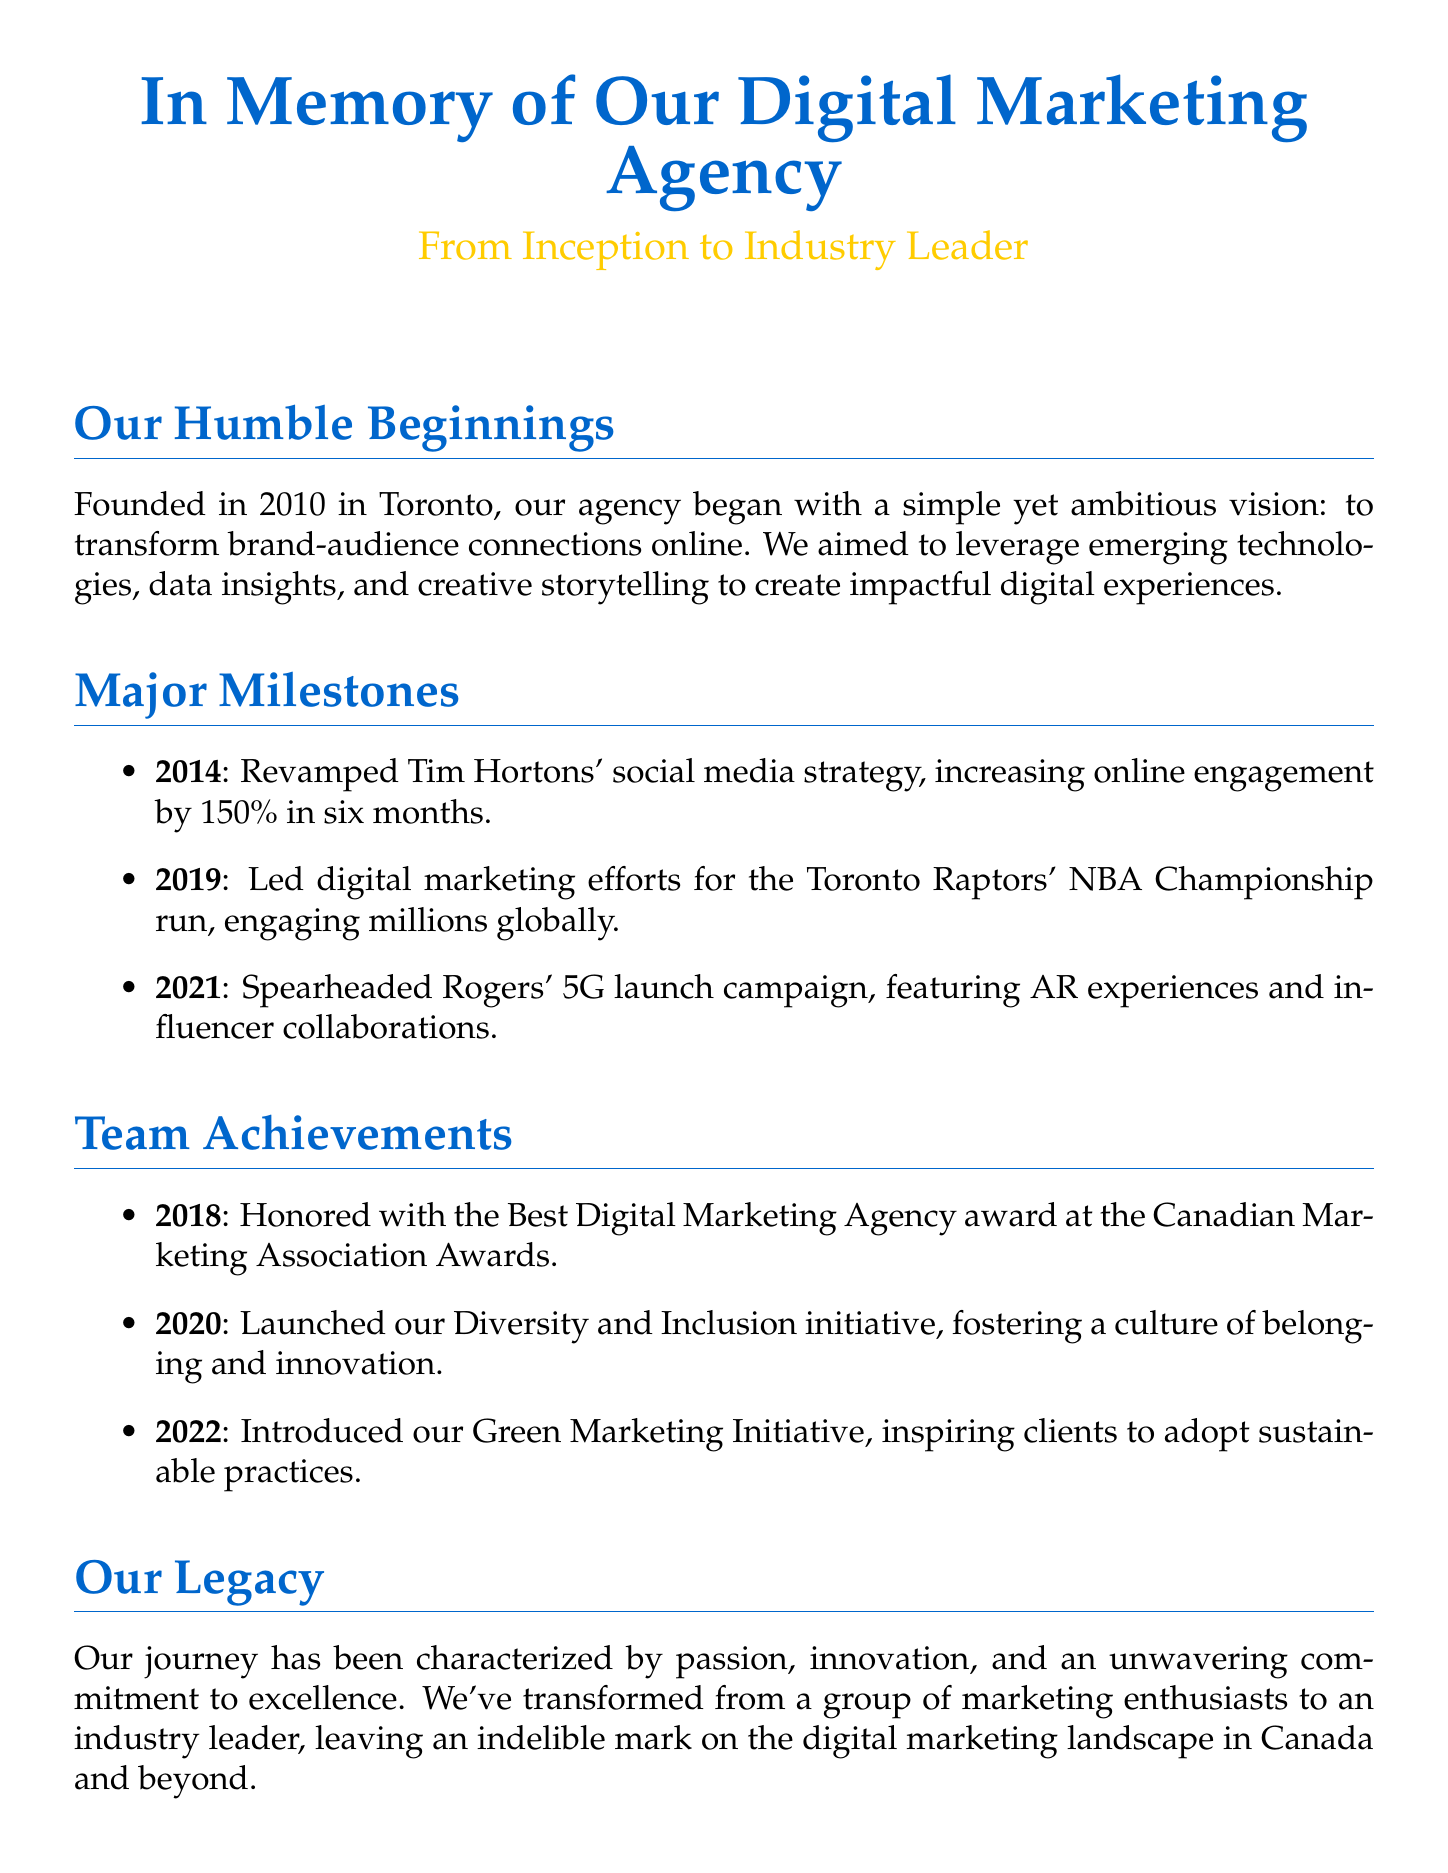what year was the agency founded? The document states that the agency was founded in 2010.
Answer: 2010 what percentage did online engagement increase for Tim Hortons? The document mentions that engagement increased by 150% in six months.
Answer: 150% which award did the agency win in 2018? The document states that the agency was honored with the Best Digital Marketing Agency award.
Answer: Best Digital Marketing Agency what major event did the agency lead marketing efforts for in 2019? According to the document, the agency led efforts for the Toronto Raptors' NBA Championship run.
Answer: Toronto Raptors' NBA Championship run what initiative was launched in 2020? The document states that the agency launched a Diversity and Inclusion initiative.
Answer: Diversity and Inclusion initiative how many major milestones are listed in the document? There are three major milestones mentioned in the document.
Answer: 3 what does the agency’s legacy emphasize? The document highlights passion, innovation, and an unwavering commitment to excellence.
Answer: passion, innovation, and an unwavering commitment to excellence what did the Green Marketing Initiative inspire? The document indicates that the initiative inspired clients to adopt sustainable practices.
Answer: adopt sustainable practices 